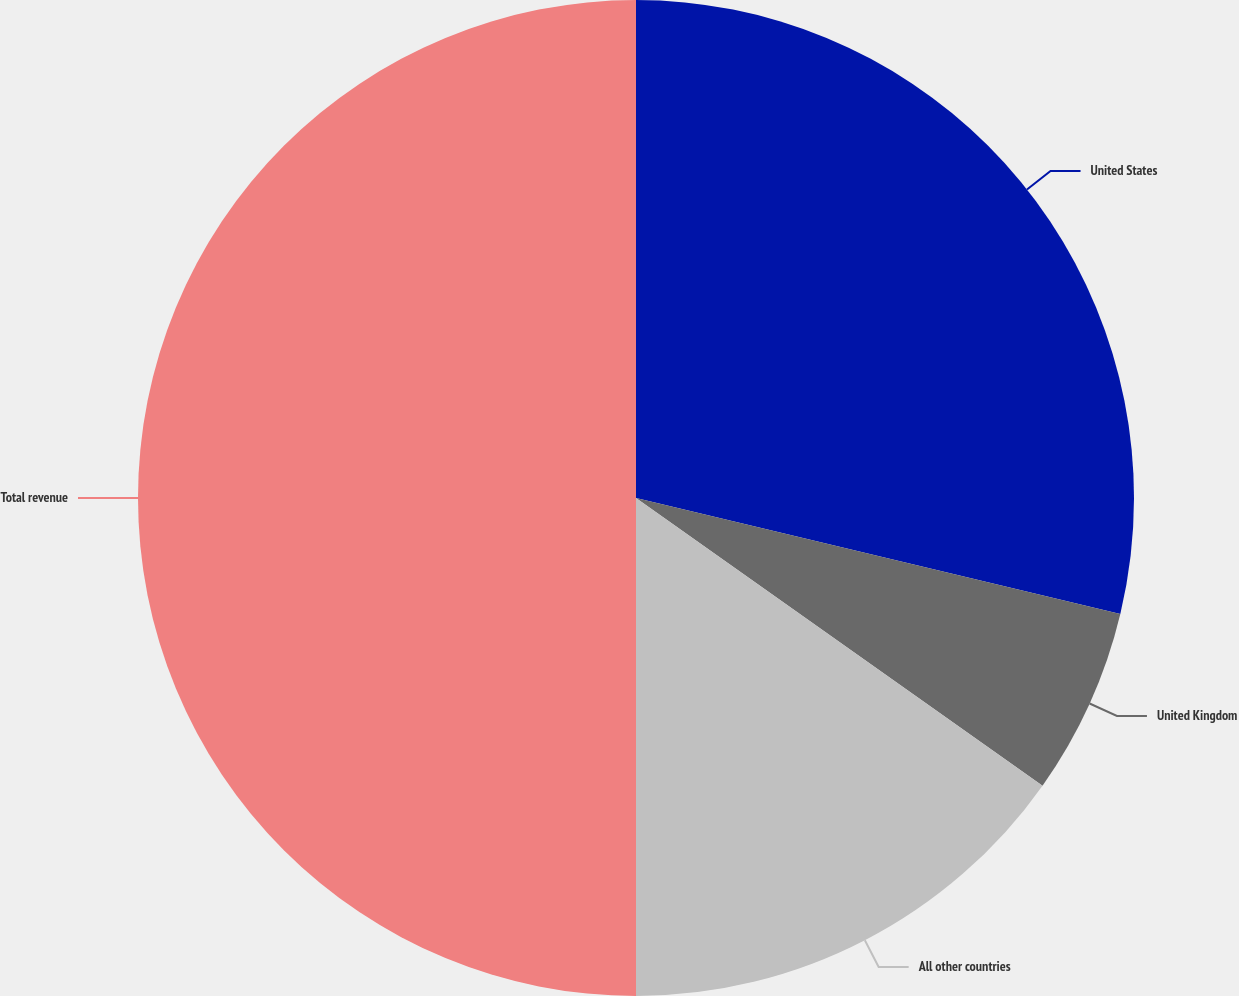<chart> <loc_0><loc_0><loc_500><loc_500><pie_chart><fcel>United States<fcel>United Kingdom<fcel>All other countries<fcel>Total revenue<nl><fcel>28.74%<fcel>6.06%<fcel>15.2%<fcel>50.0%<nl></chart> 